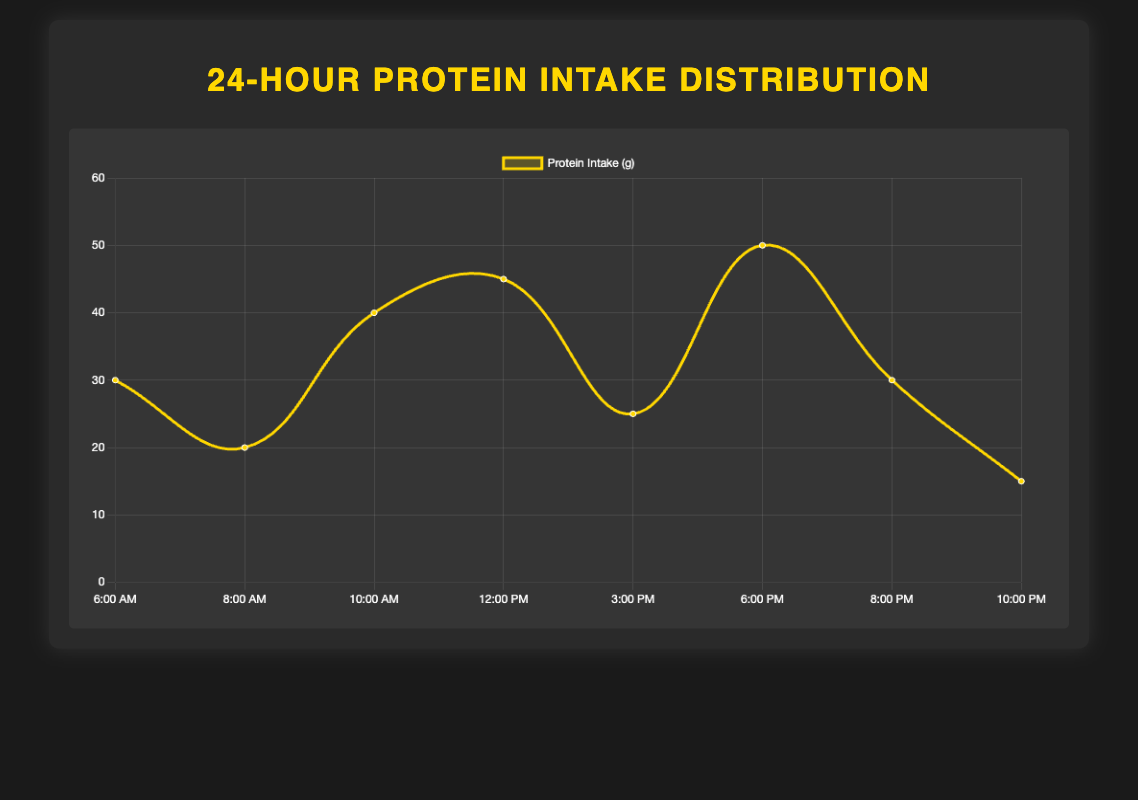What is the total amount of protein intake from all sources throughout the day? Sum all the protein amounts: 30g (Egg Whites) + 20g (Greek Yogurt) + 40g (Whey Protein Isolate) + 45g (Grilled Chicken Breast) + 25g (Cottage Cheese) + 50g (Salmon Fillet) + 30g (Casein Protein Shake) + 15g (Almonds). The total is 30 + 20 + 40 + 45 + 25 + 50 + 30 + 15 = 255g
Answer: 255g Which time period has the highest protein intake? Identify the highest value on the plot and check the associated time period. The highest value is 50g, corresponding to Dinner at 6:00 PM
Answer: Dinner at 6:00 PM Which time period has the lowest protein intake? Identify the lowest value on the plot and check the associated time period. The lowest value is 15g, corresponding to Before Bed at 10:00 PM
Answer: Before Bed at 10:00 PM What is the combined protein intake from pre-workout meals? Add the protein amounts from Pre-Workout Breakfast (30g) and Pre-Workout Snack (20g). The total is 30g + 20g = 50g
Answer: 50g How does the protein intake at Lunch compare to the protein intake at Dinner? Check the protein amounts at Lunch (12:00 PM) and Dinner (6:00 PM). Lunch has 45g and Dinner has 50g. Dinner has 5g more protein than Lunch
Answer: Dinner has 5g more protein than Lunch What is the average protein intake per meal/snack? Total protein intake is 255g, and there are 8 meals/snacks. The average is 255g / 8 = 31.875g
Answer: 31.875g Calculate the difference in protein intake between the highest and lowest protein sources. The highest intake is 50g (Dinner at 6:00 PM) and the lowest is 15g (Before Bed at 10:00 PM). The difference is 50g - 15g = 35g
Answer: 35g What color represents the protein intake line on the plot? The protein intake line is represented with the color yellow
Answer: Yellow 